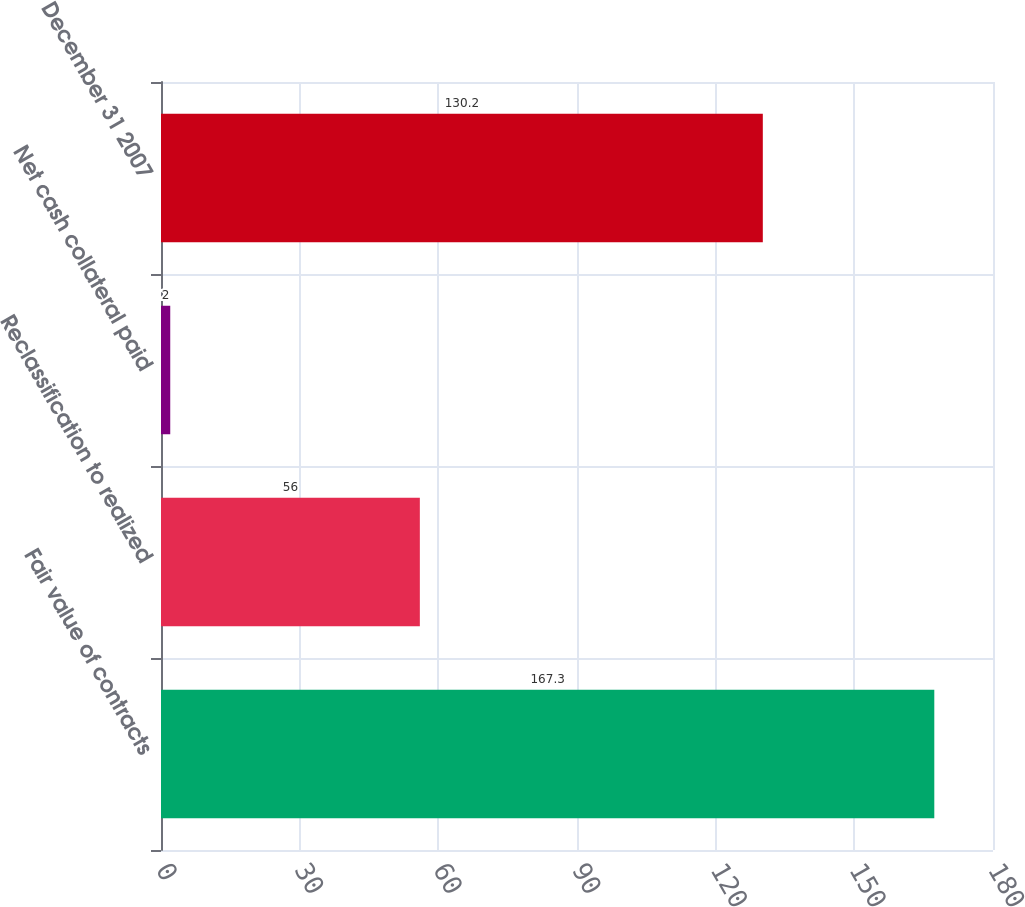Convert chart to OTSL. <chart><loc_0><loc_0><loc_500><loc_500><bar_chart><fcel>Fair value of contracts<fcel>Reclassification to realized<fcel>Net cash collateral paid<fcel>December 31 2007<nl><fcel>167.3<fcel>56<fcel>2<fcel>130.2<nl></chart> 